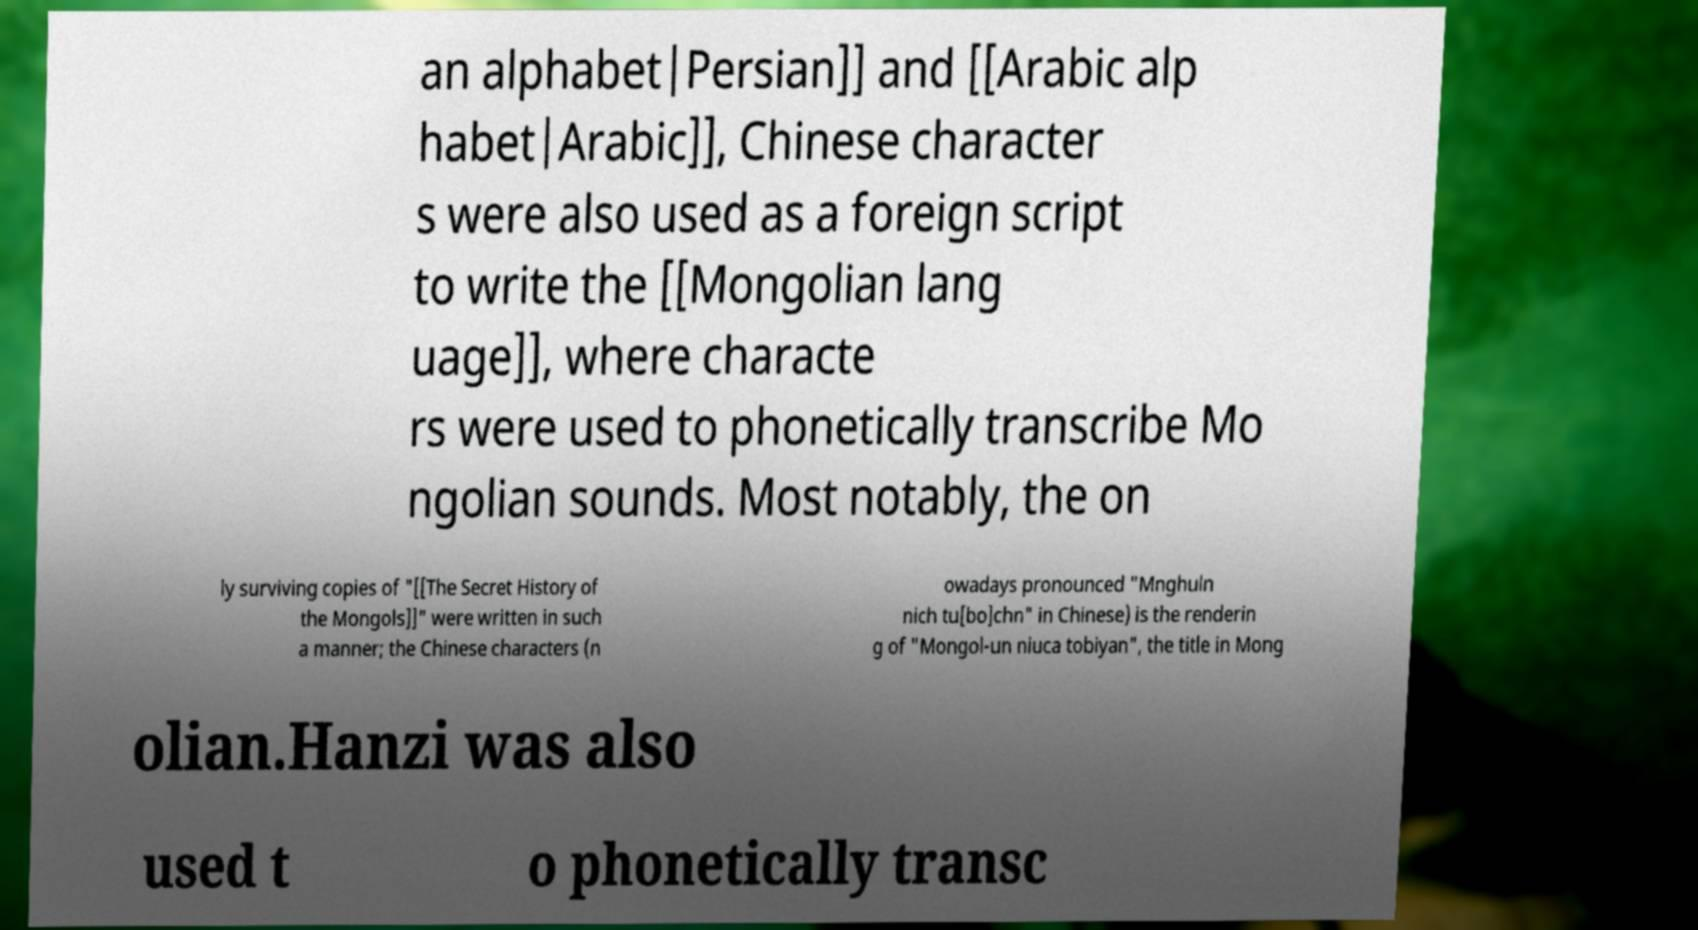What messages or text are displayed in this image? I need them in a readable, typed format. an alphabet|Persian]] and [[Arabic alp habet|Arabic]], Chinese character s were also used as a foreign script to write the [[Mongolian lang uage]], where characte rs were used to phonetically transcribe Mo ngolian sounds. Most notably, the on ly surviving copies of "[[The Secret History of the Mongols]]" were written in such a manner; the Chinese characters (n owadays pronounced "Mnghuln nich tu[bo]chn" in Chinese) is the renderin g of "Mongol-un niuca tobiyan", the title in Mong olian.Hanzi was also used t o phonetically transc 